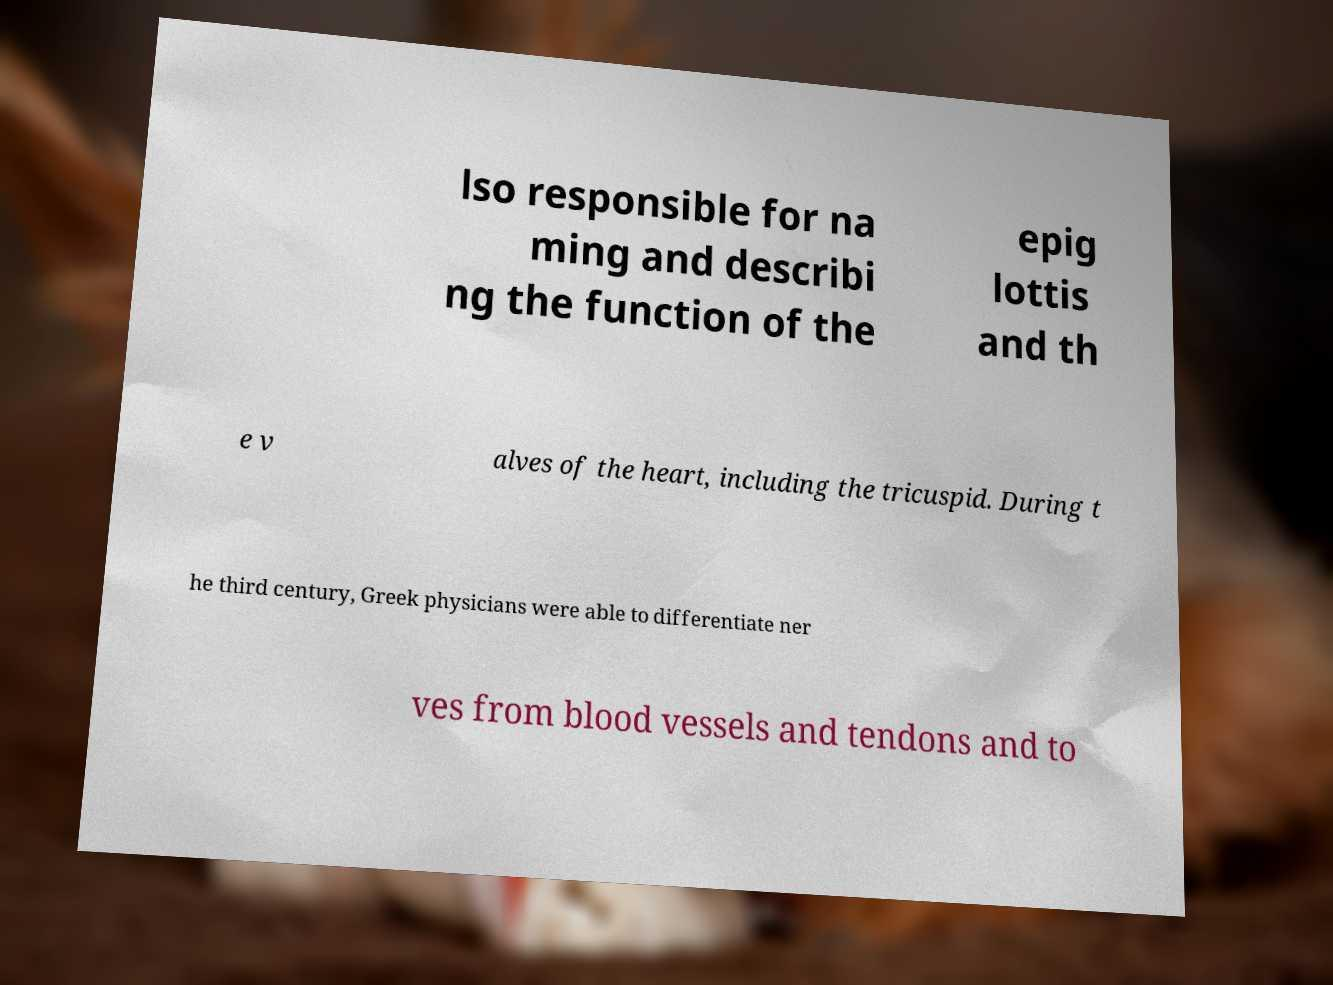Could you extract and type out the text from this image? lso responsible for na ming and describi ng the function of the epig lottis and th e v alves of the heart, including the tricuspid. During t he third century, Greek physicians were able to differentiate ner ves from blood vessels and tendons and to 